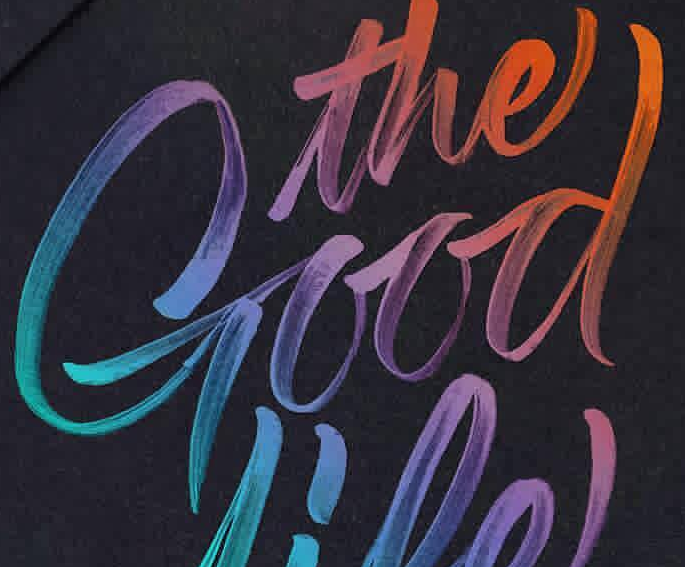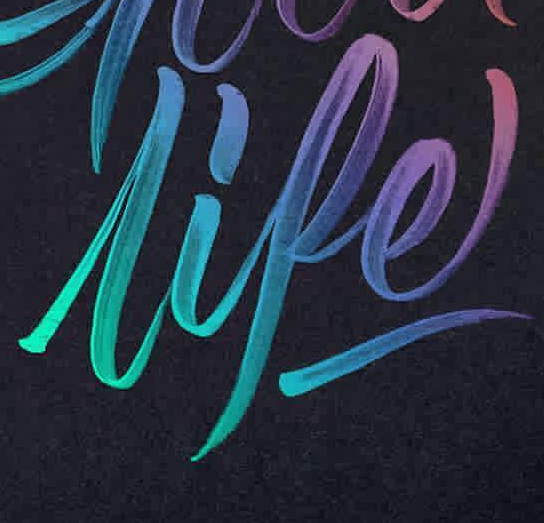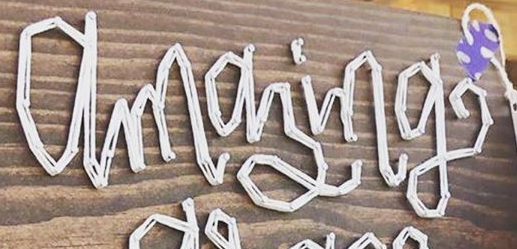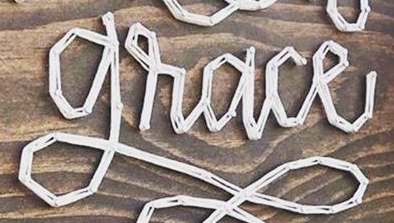Read the text from these images in sequence, separated by a semicolon. Good; lipe; amazing; grace 